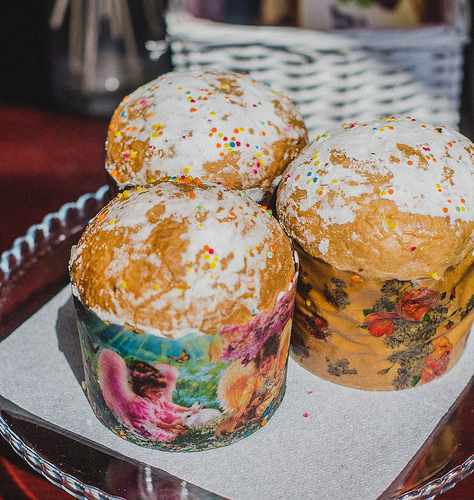<image>
Is there a cake in the basket? No. The cake is not contained within the basket. These objects have a different spatial relationship. Is the muffins next to the basket? Yes. The muffins is positioned adjacent to the basket, located nearby in the same general area. 